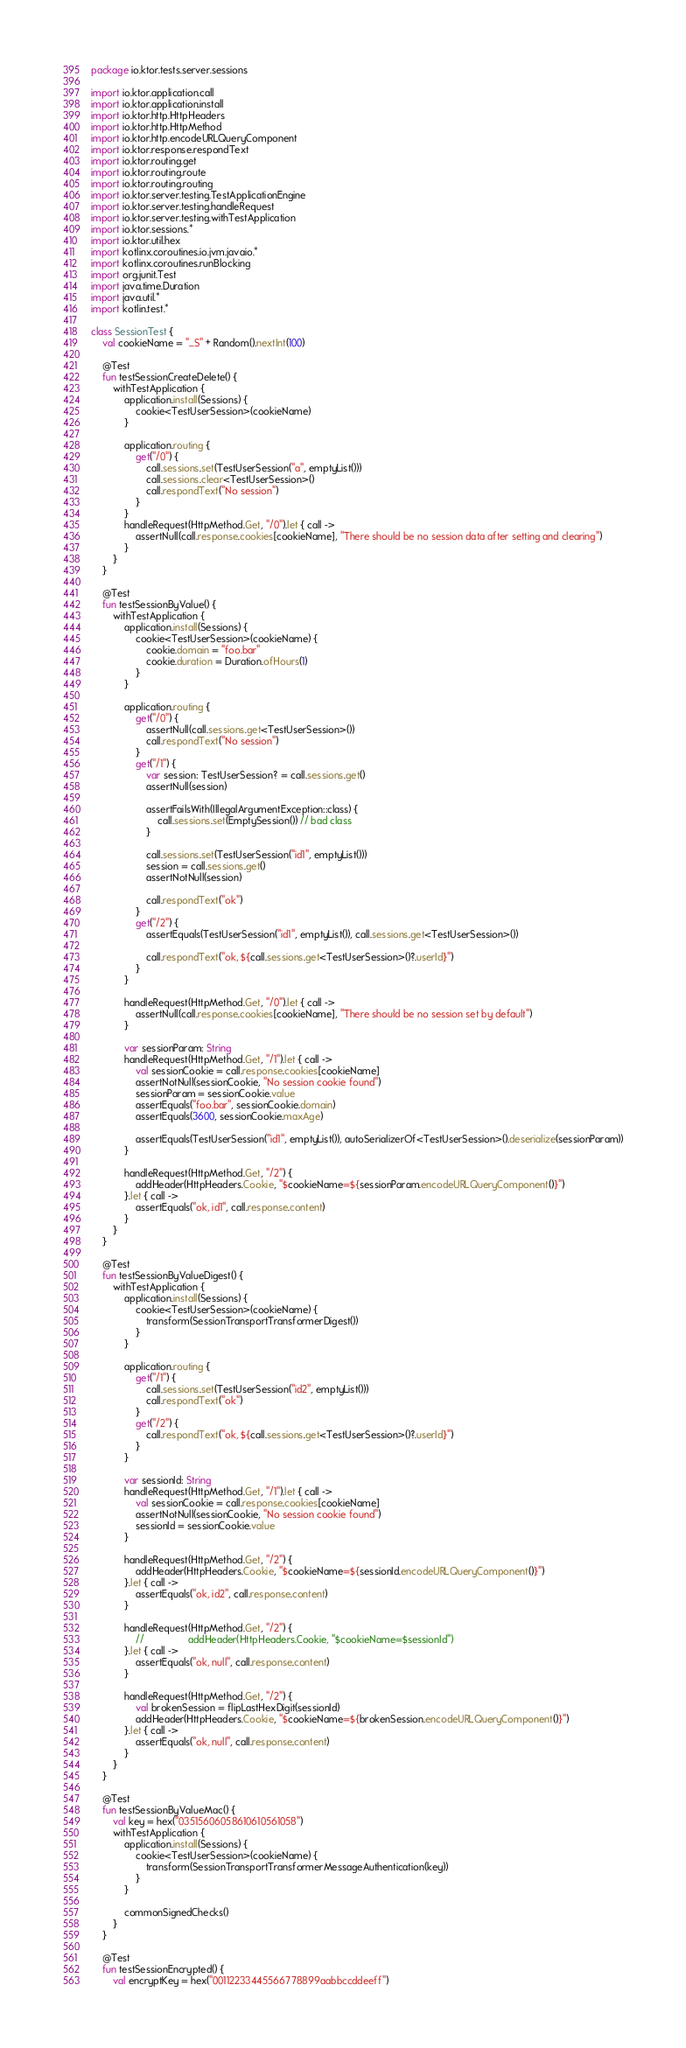<code> <loc_0><loc_0><loc_500><loc_500><_Kotlin_>package io.ktor.tests.server.sessions

import io.ktor.application.call
import io.ktor.application.install
import io.ktor.http.HttpHeaders
import io.ktor.http.HttpMethod
import io.ktor.http.encodeURLQueryComponent
import io.ktor.response.respondText
import io.ktor.routing.get
import io.ktor.routing.route
import io.ktor.routing.routing
import io.ktor.server.testing.TestApplicationEngine
import io.ktor.server.testing.handleRequest
import io.ktor.server.testing.withTestApplication
import io.ktor.sessions.*
import io.ktor.util.hex
import kotlinx.coroutines.io.jvm.javaio.*
import kotlinx.coroutines.runBlocking
import org.junit.Test
import java.time.Duration
import java.util.*
import kotlin.test.*

class SessionTest {
    val cookieName = "_S" + Random().nextInt(100)

    @Test
    fun testSessionCreateDelete() {
        withTestApplication {
            application.install(Sessions) {
                cookie<TestUserSession>(cookieName)
            }

            application.routing {
                get("/0") {
                    call.sessions.set(TestUserSession("a", emptyList()))
                    call.sessions.clear<TestUserSession>()
                    call.respondText("No session")
                }
            }
            handleRequest(HttpMethod.Get, "/0").let { call ->
                assertNull(call.response.cookies[cookieName], "There should be no session data after setting and clearing")
            }
        }
    }

    @Test
    fun testSessionByValue() {
        withTestApplication {
            application.install(Sessions) {
                cookie<TestUserSession>(cookieName) {
                    cookie.domain = "foo.bar"
                    cookie.duration = Duration.ofHours(1)
                }
            }

            application.routing {
                get("/0") {
                    assertNull(call.sessions.get<TestUserSession>())
                    call.respondText("No session")
                }
                get("/1") {
                    var session: TestUserSession? = call.sessions.get()
                    assertNull(session)

                    assertFailsWith(IllegalArgumentException::class) {
                        call.sessions.set(EmptySession()) // bad class
                    }

                    call.sessions.set(TestUserSession("id1", emptyList()))
                    session = call.sessions.get()
                    assertNotNull(session)

                    call.respondText("ok")
                }
                get("/2") {
                    assertEquals(TestUserSession("id1", emptyList()), call.sessions.get<TestUserSession>())

                    call.respondText("ok, ${call.sessions.get<TestUserSession>()?.userId}")
                }
            }

            handleRequest(HttpMethod.Get, "/0").let { call ->
                assertNull(call.response.cookies[cookieName], "There should be no session set by default")
            }

            var sessionParam: String
            handleRequest(HttpMethod.Get, "/1").let { call ->
                val sessionCookie = call.response.cookies[cookieName]
                assertNotNull(sessionCookie, "No session cookie found")
                sessionParam = sessionCookie.value
                assertEquals("foo.bar", sessionCookie.domain)
                assertEquals(3600, sessionCookie.maxAge)

                assertEquals(TestUserSession("id1", emptyList()), autoSerializerOf<TestUserSession>().deserialize(sessionParam))
            }

            handleRequest(HttpMethod.Get, "/2") {
                addHeader(HttpHeaders.Cookie, "$cookieName=${sessionParam.encodeURLQueryComponent()}")
            }.let { call ->
                assertEquals("ok, id1", call.response.content)
            }
        }
    }

    @Test
    fun testSessionByValueDigest() {
        withTestApplication {
            application.install(Sessions) {
                cookie<TestUserSession>(cookieName) {
                    transform(SessionTransportTransformerDigest())
                }
            }

            application.routing {
                get("/1") {
                    call.sessions.set(TestUserSession("id2", emptyList()))
                    call.respondText("ok")
                }
                get("/2") {
                    call.respondText("ok, ${call.sessions.get<TestUserSession>()?.userId}")
                }
            }

            var sessionId: String
            handleRequest(HttpMethod.Get, "/1").let { call ->
                val sessionCookie = call.response.cookies[cookieName]
                assertNotNull(sessionCookie, "No session cookie found")
                sessionId = sessionCookie.value
            }

            handleRequest(HttpMethod.Get, "/2") {
                addHeader(HttpHeaders.Cookie, "$cookieName=${sessionId.encodeURLQueryComponent()}")
            }.let { call ->
                assertEquals("ok, id2", call.response.content)
            }

            handleRequest(HttpMethod.Get, "/2") {
                //                addHeader(HttpHeaders.Cookie, "$cookieName=$sessionId")
            }.let { call ->
                assertEquals("ok, null", call.response.content)
            }

            handleRequest(HttpMethod.Get, "/2") {
                val brokenSession = flipLastHexDigit(sessionId)
                addHeader(HttpHeaders.Cookie, "$cookieName=${brokenSession.encodeURLQueryComponent()}")
            }.let { call ->
                assertEquals("ok, null", call.response.content)
            }
        }
    }

    @Test
    fun testSessionByValueMac() {
        val key = hex("03515606058610610561058")
        withTestApplication {
            application.install(Sessions) {
                cookie<TestUserSession>(cookieName) {
                    transform(SessionTransportTransformerMessageAuthentication(key))
                }
            }

            commonSignedChecks()
        }
    }

    @Test
    fun testSessionEncrypted() {
        val encryptKey = hex("00112233445566778899aabbccddeeff")</code> 